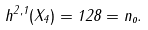Convert formula to latex. <formula><loc_0><loc_0><loc_500><loc_500>h ^ { 2 , 1 } ( X _ { 4 } ) = 1 2 8 = n _ { o } .</formula> 